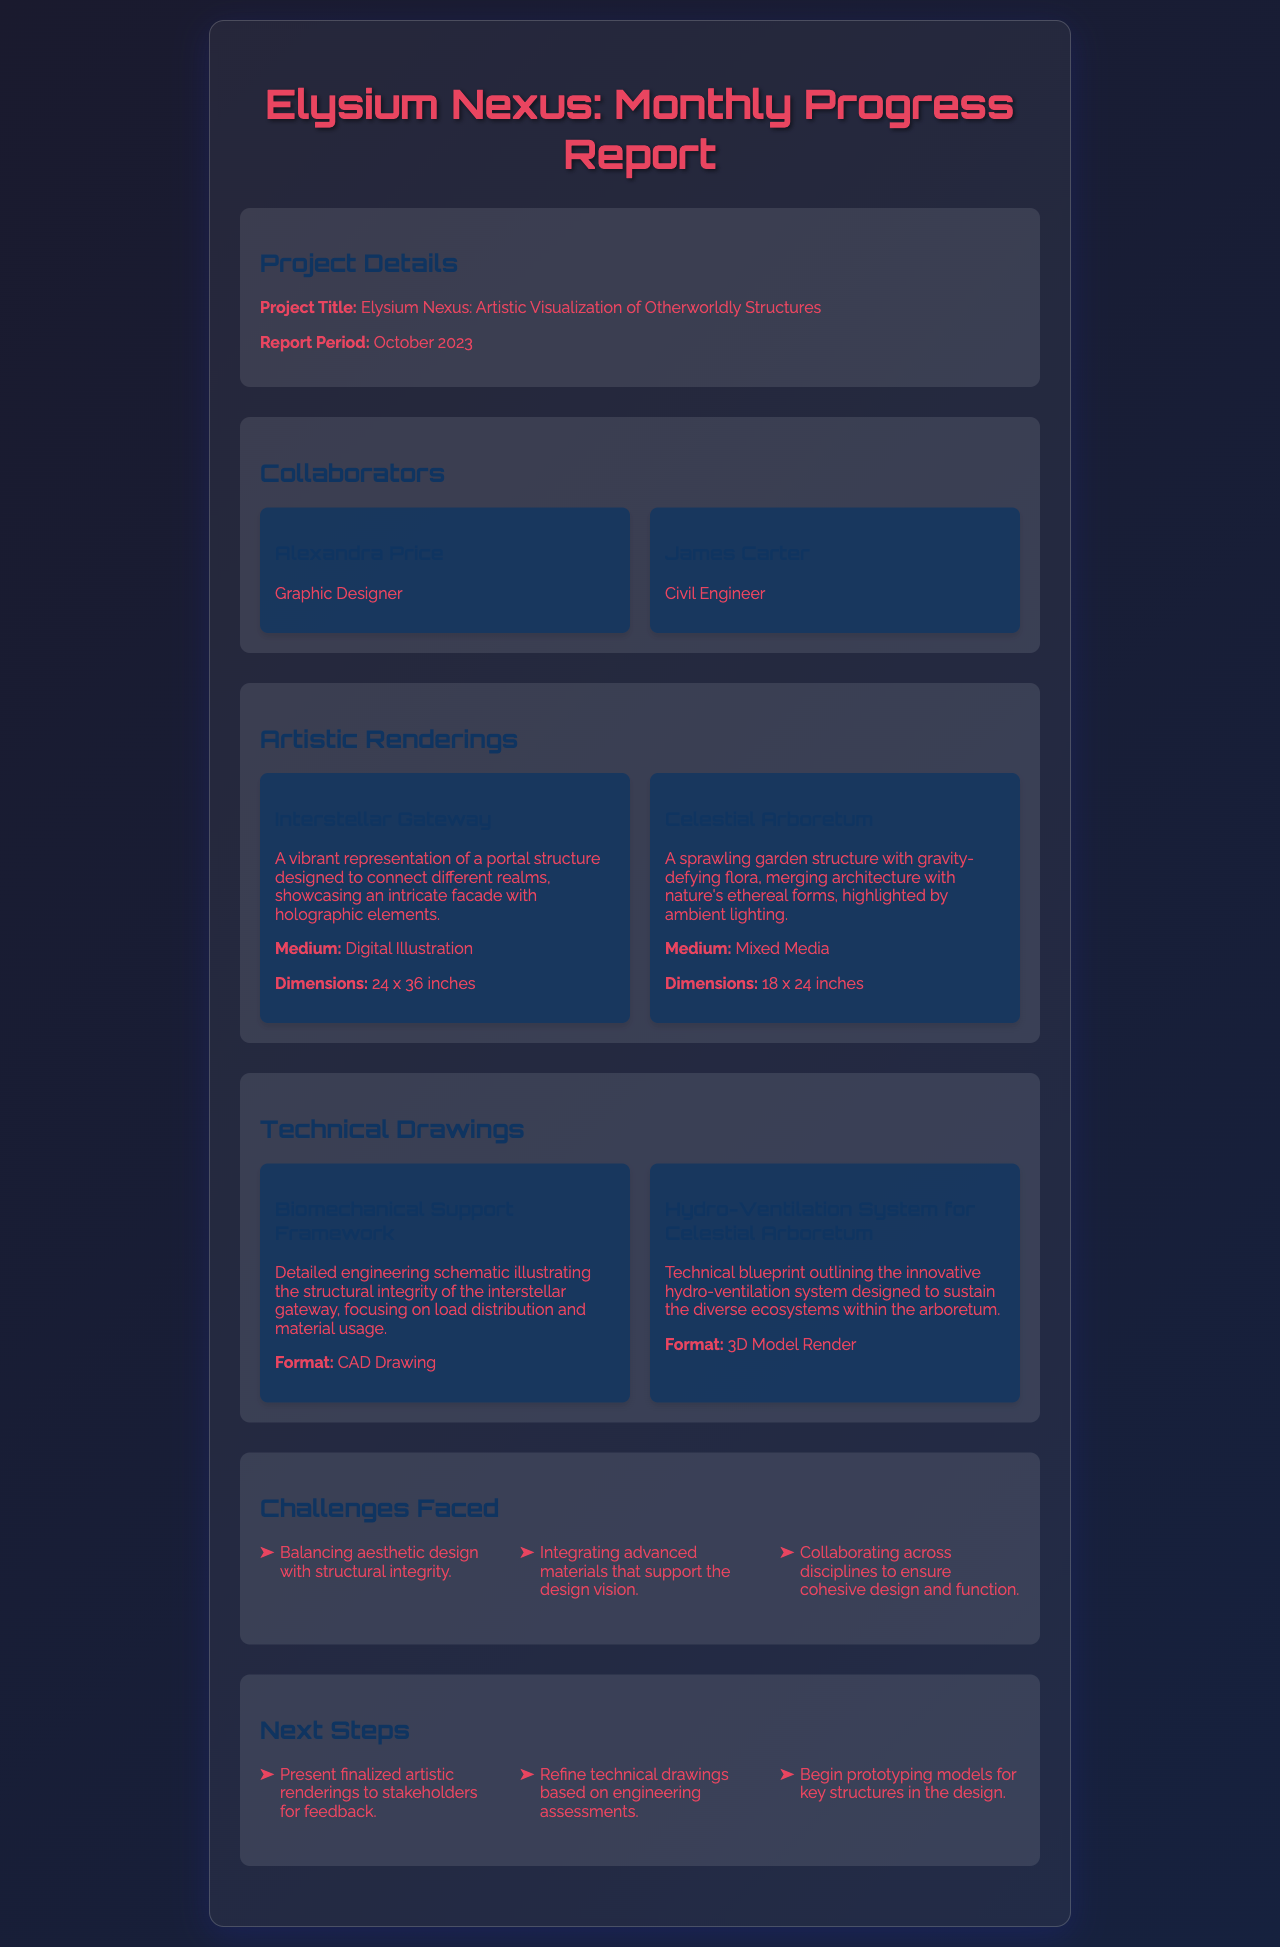What is the project title? The project title is stated prominently in the project details section.
Answer: Elysium Nexus: Artistic Visualization of Otherworldly Structures Who is the civil engineer collaborating on the project? The document lists the collaborators and their roles, including the civil engineer.
Answer: James Carter What is the medium used for "Interstellar Gateway"? The medium used for this artistic rendering is specified in the renderings section.
Answer: Digital Illustration How many dimensions are provided for the "Celestial Arboretum"? The dimensions are detailed for each artistic rendering, which is a key piece of information provided.
Answer: 18 x 24 inches What color theme is used in the document’s background? The background color design can be deduced from the styling of the document.
Answer: Gradient of dark colors What challenges did the team face? The document lists challenges faced in an unordered list format.
Answer: Balancing aesthetic design with structural integrity Which technical drawing outlines the hydro-ventilation system? The title of the technical drawing is specified in the technical drawings section.
Answer: Hydro-Ventilation System for Celestial Arboretum What is one of the next steps mentioned? The next steps are listed as actionable items in the project report.
Answer: Present finalized artistic renderings to stakeholders for feedback 